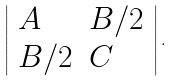Convert formula to latex. <formula><loc_0><loc_0><loc_500><loc_500>\left | { \begin{array} { l l } { A } & { B / 2 } \\ { B / 2 } & { C } \end{array} } \right | .</formula> 